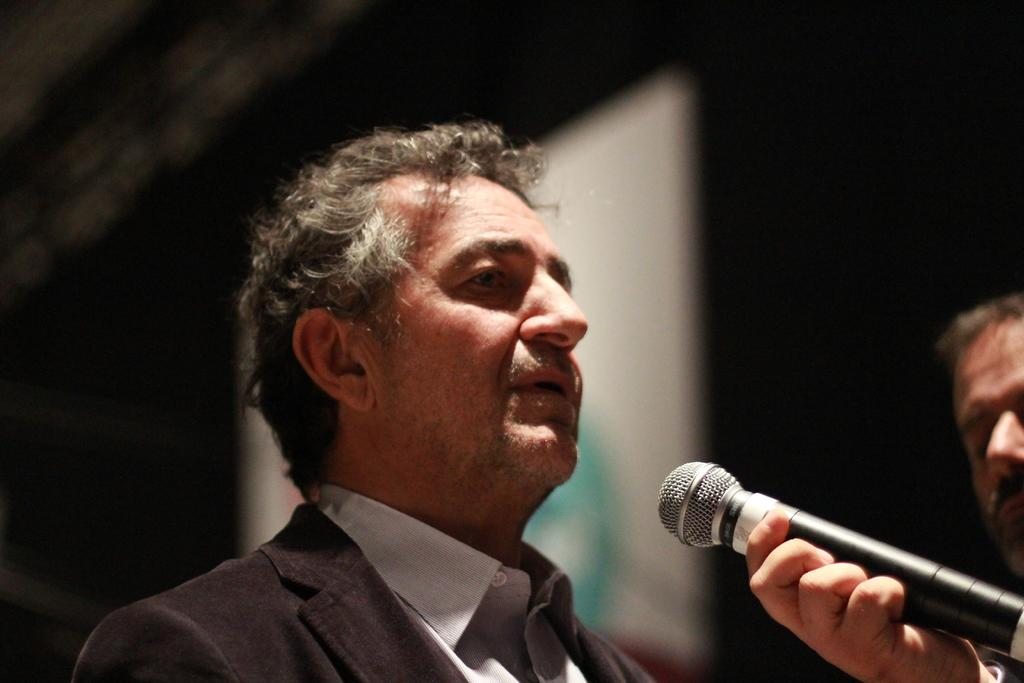Who or what is the main subject of the image? There is a person in the image. Where is the person located in the image? The person is in the center of the image. What is the person doing in the image? The person is speaking on a microphone. What type of rose is the person holding in the image? There is no rose present in the image; the person is speaking on a microphone. How many pieces of paper can be seen on the floor near the person? There is no paper visible in the image; the person is speaking on a microphone. 